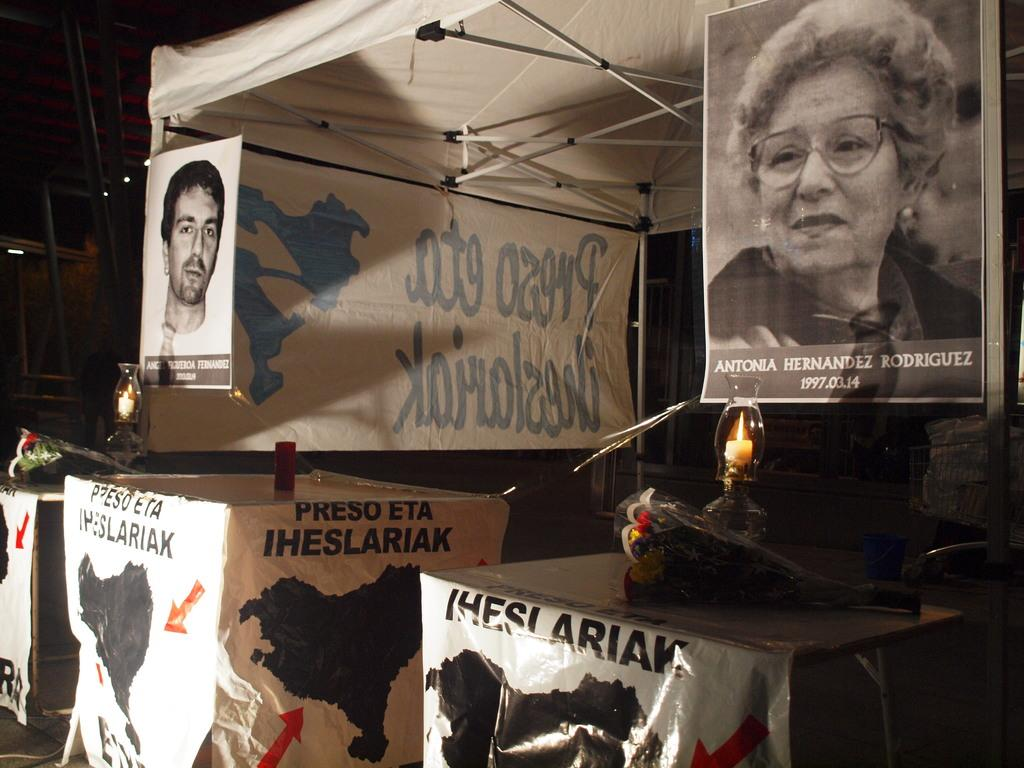What objects can be seen in the image? There are posts, two candles, and a tent visible in the image. Where are the candles located in the image? The two candles are in the center of the image. What structure is visible at the top of the image? There is a tent visible at the top of the image. Can you tell me how many pieces of paper are on the ground in the image? There is no paper visible on the ground in the image. What type of monkey can be seen interacting with the candles in the image? There is no monkey present in the image; it only features posts, candles, and a tent. 